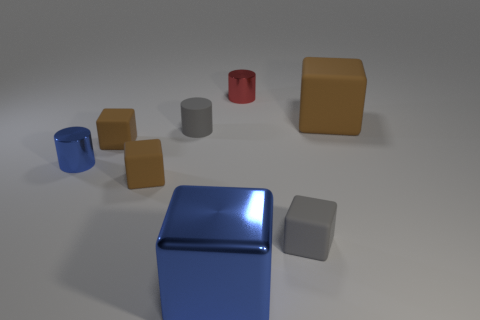Subtract all brown blocks. How many were subtracted if there are1brown blocks left? 2 Subtract all gray spheres. How many brown cubes are left? 3 Subtract all small gray rubber cubes. How many cubes are left? 4 Subtract all gray blocks. How many blocks are left? 4 Subtract all cyan blocks. Subtract all purple spheres. How many blocks are left? 5 Add 1 blue shiny cylinders. How many objects exist? 9 Subtract all cubes. How many objects are left? 3 Add 6 blue cylinders. How many blue cylinders are left? 7 Add 3 tiny things. How many tiny things exist? 9 Subtract 0 cyan cylinders. How many objects are left? 8 